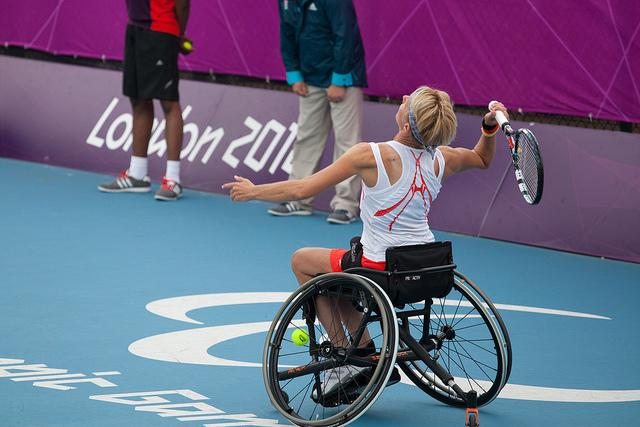In which class of the sport does the tennis player compete? special olympics 